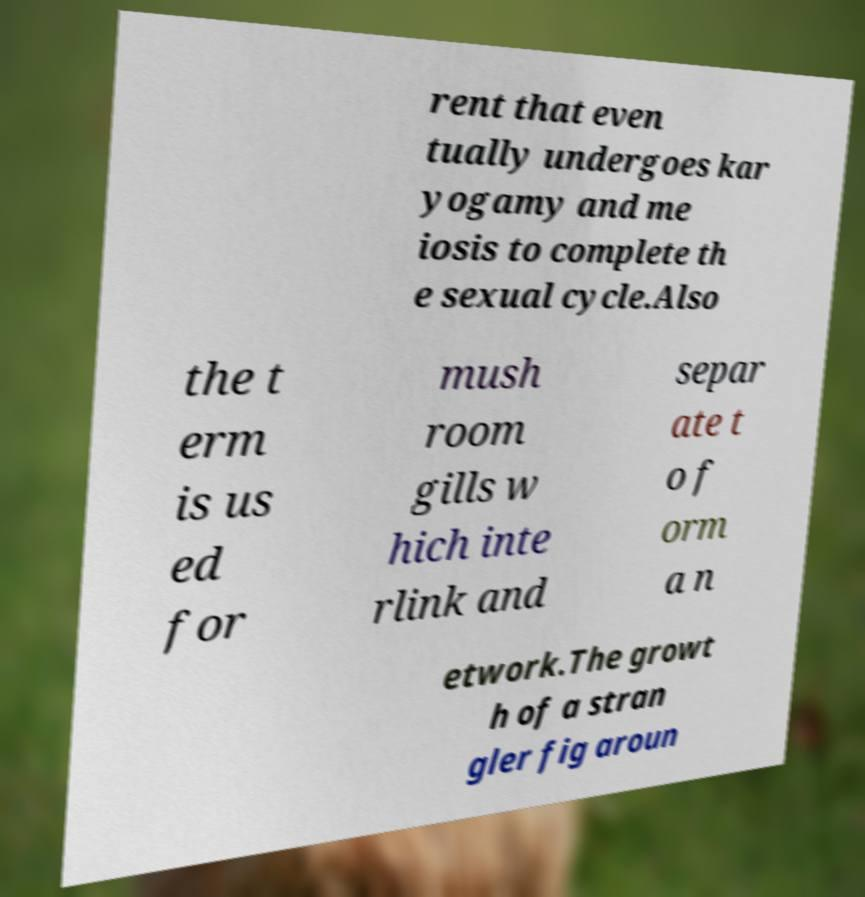Please identify and transcribe the text found in this image. rent that even tually undergoes kar yogamy and me iosis to complete th e sexual cycle.Also the t erm is us ed for mush room gills w hich inte rlink and separ ate t o f orm a n etwork.The growt h of a stran gler fig aroun 